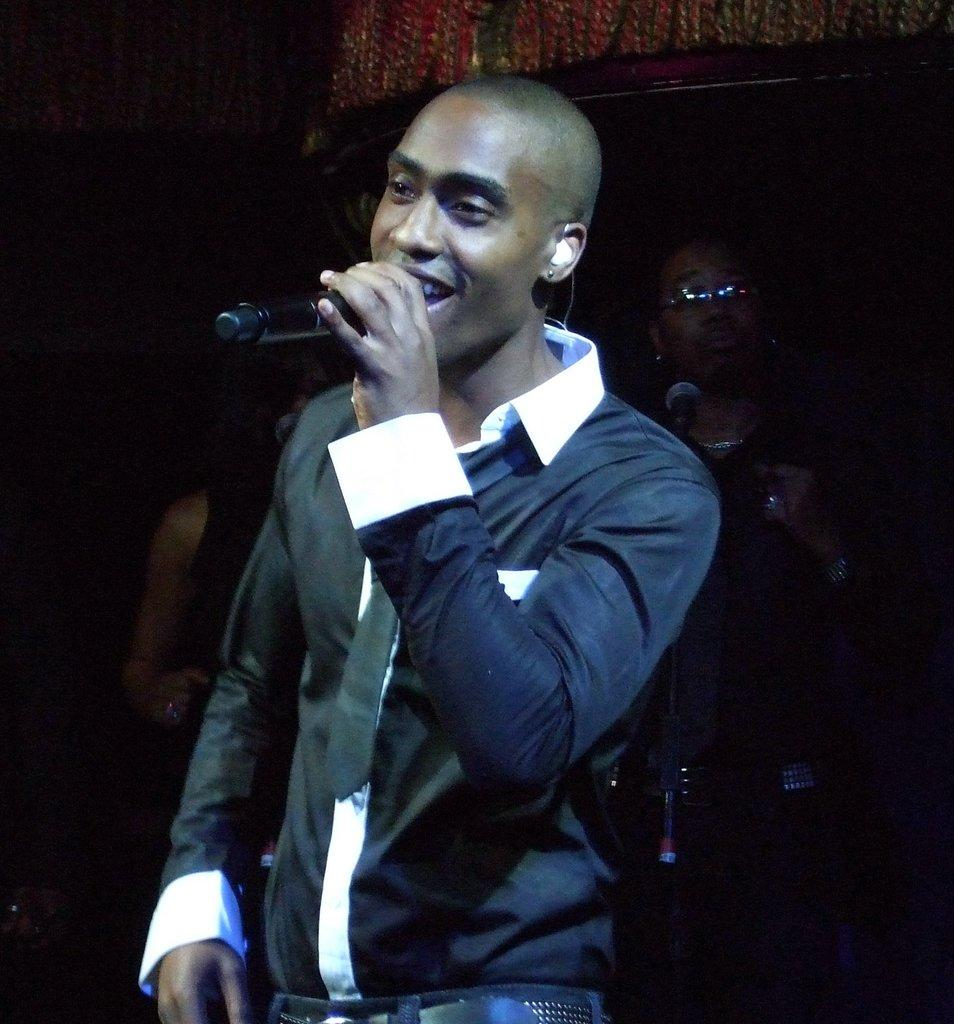What is the man in the image doing? The man is standing and singing in the image. Are there any other people present in the image? Yes, there are people behind the man in the image. What type of knee injury is the man experiencing in the image? There is no indication of a knee injury in the image; the man is standing and singing. What time of day is it in the image? The time of day is not mentioned in the image, so it cannot be determined. 